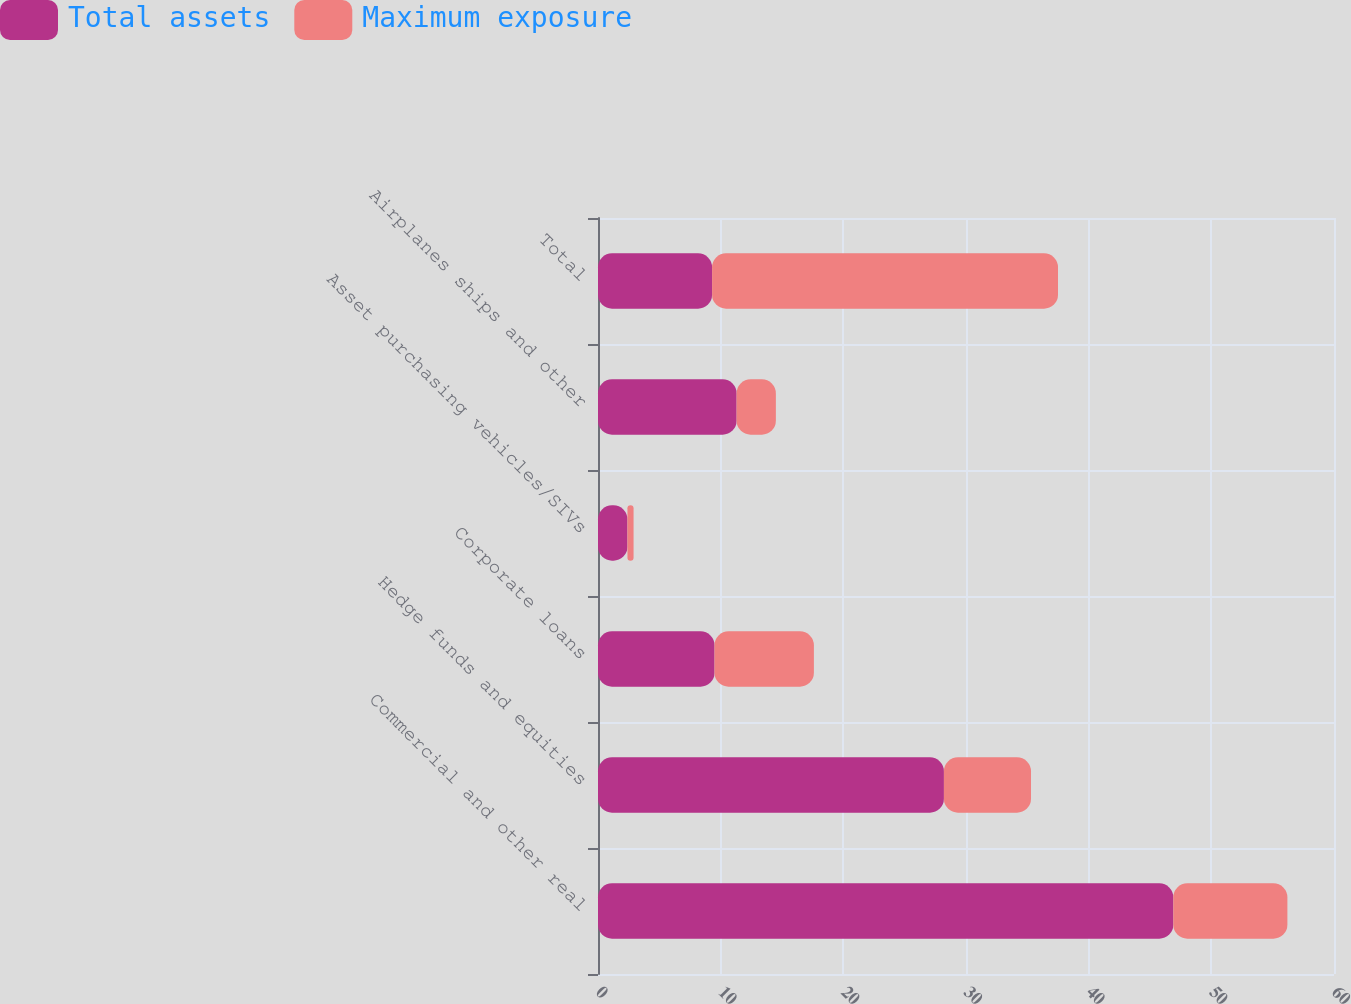Convert chart. <chart><loc_0><loc_0><loc_500><loc_500><stacked_bar_chart><ecel><fcel>Commercial and other real<fcel>Hedge funds and equities<fcel>Corporate loans<fcel>Asset purchasing vehicles/SIVs<fcel>Airplanes ships and other<fcel>Total<nl><fcel>Total assets<fcel>46.9<fcel>28.2<fcel>9.5<fcel>2.4<fcel>11.3<fcel>9.3<nl><fcel>Maximum exposure<fcel>9.3<fcel>7.1<fcel>8.1<fcel>0.5<fcel>3.2<fcel>28.2<nl></chart> 